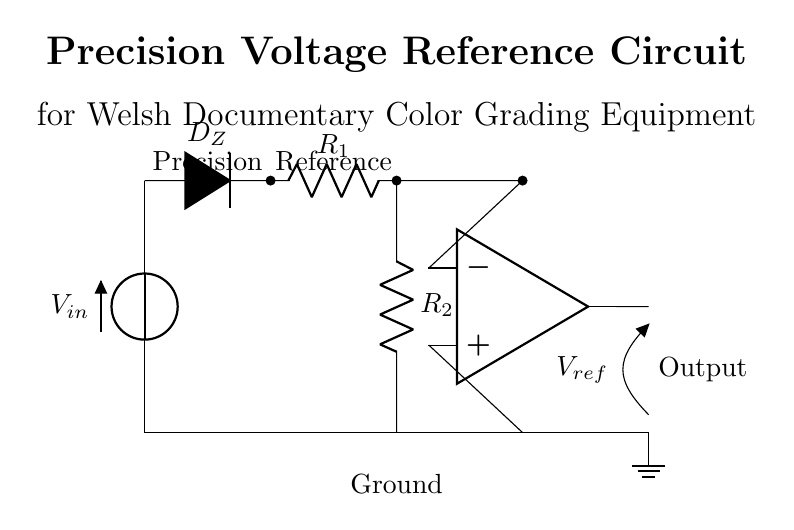What type of diode is used in this circuit? The circuit shows a Zener diode, which is indicated by the symbol 'D*' attached to the label '$D_Z$'. Zener diodes are commonly used for voltage regulation.
Answer: Zener diode What is the function of the operational amplifier in this circuit? The operational amplifier is configured to provide a stable output voltage reference ($V_{ref}$). It compares the input voltage and adjusts the output accordingly to maintain the desired precision for color grading.
Answer: Reference voltage How many resistors are present in the circuit? There are two resistors indicated by the labels '$R_1$' and '$R_2$', which are shown in series with the other components.
Answer: Two resistors What is the role of the Zener diode in this precision voltage reference circuit? The Zener diode regulates the voltage across itself to provide a constant voltage reference. It operates in reverse bias, maintaining a steady voltage level necessary for the operational amplifier's function.
Answer: Voltage regulation What is the output voltage of the circuit intended to be for calibration? The output voltage $V_{ref}$ is crucial for calibrating equipment used in post-production, but the specific value is not given in the diagram; it largely depends on the input voltage and the diode's characteristics.
Answer: Variable What do the labels "Precision" and "Reference" above the Zener diode indicate? The labels suggest the main purpose of the circuit: to provide a precise voltage reference for applications like color grading, indicating the importance of accuracy and stability in the output.
Answer: Precision reference How does this circuit contribute to color grading in documentaries? This circuit provides a stable voltage reference that ensures consistent color calibration across post-production equipment, which is essential for achieving high-quality visuals in documentaries.
Answer: Consistent calibration 